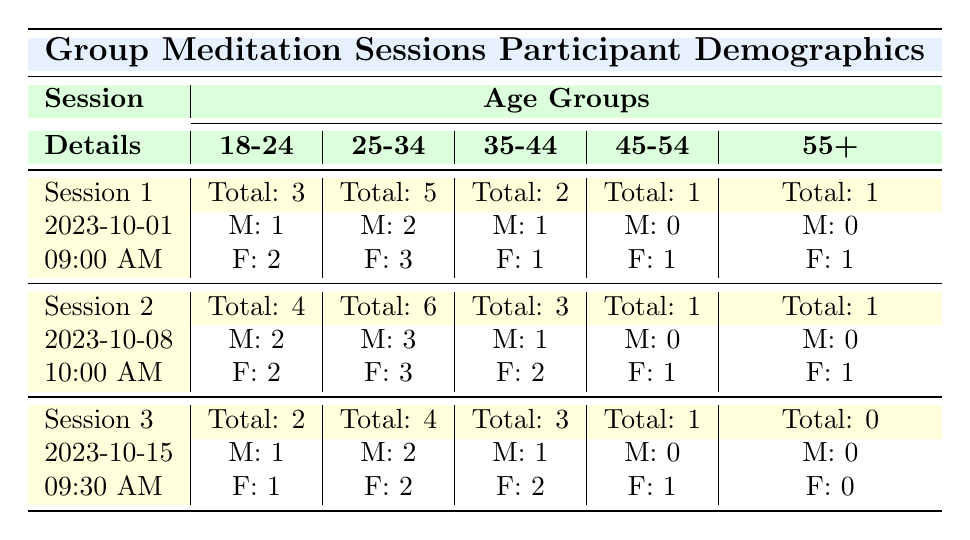What was the total number of participants in Session 1? The table shows that for Session 1, the total number of participants listed under "participants" is 12.
Answer: 12 How many male participants were there in the age group 25-34 for Session 2? In the age group 25-34 under Session 2, the gender distribution shows that there are 3 male participants.
Answer: 3 What is the total count of female participants across all sessions? We need to sum the number of female participants for each age group across all sessions. Session 1 has 6 females, Session 2 has 9 females, and Session 3 has 5 females, giving us a total of 6 + 9 + 5 = 20 females.
Answer: 20 Did Session 3 have any participants aged 55 or older? In the age group 55+ for Session 3, the count is 0, indicating that there were no participants aged 55 or older.
Answer: No Which session had the highest number of participants in the age group 18-24? By comparing the age group 18-24 across all sessions, Session 2 has the highest count with 4 participants, while Session 1 has 3 and Session 3 has 2.
Answer: Session 2 What is the combined total of male participants in the age groups 35-44 and 45-54 for Session 1? In Session 1, there is 1 male participant in the age group 35-44 and 0 in the age group 45-54. Adding them together gives us 1 + 0 = 1 male participant in these age groups.
Answer: 1 How many male and female participants were there in Session 3? In Session 3, there are a total of 6 (1 male in 18-24, 2 males in 25-34, 1 male in 35-44, 0 males in 45-54, and 0 males in 55+) male participants and 5 (1 female in 18-24, 2 females in 25-34, 2 females in 35-44, 1 female in 45-54) female participants, totaling 6 males and 5 females combined.
Answer: 6 males and 5 females Was there a session with no participants aged 55 or older? Yes, in Session 3, there were no participants in the age group of 55 or older as the count is 0.
Answer: Yes 